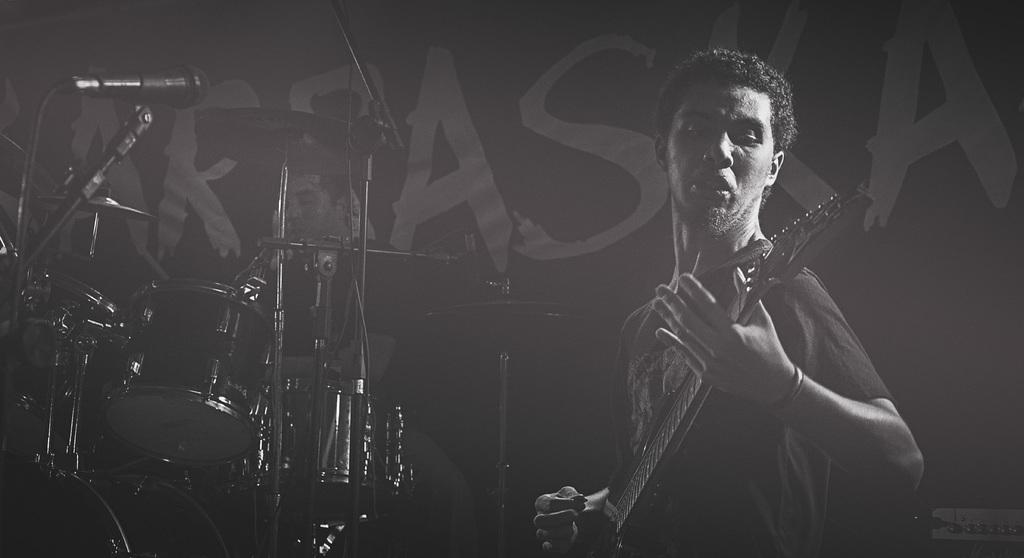What is the man in the foreground of the image doing? The man in the foreground of the image is playing a guitar. What musical instrument is visible behind the man? There are drums visible behind the man. Is there anyone else present in the image? Yes, there is a person behind the drums. What type of servant can be seen attending to the cart in the image? There is no servant or cart present in the image. 